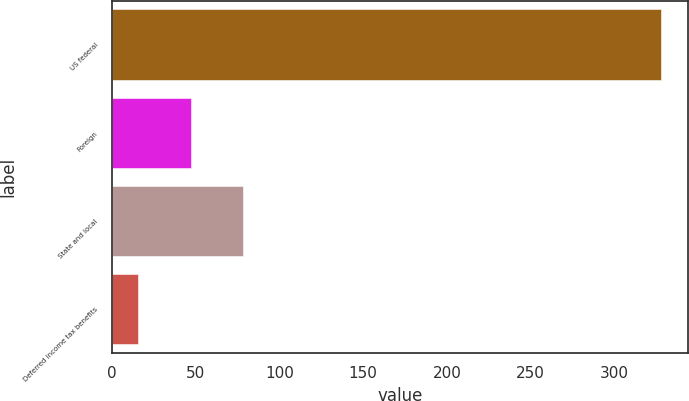Convert chart to OTSL. <chart><loc_0><loc_0><loc_500><loc_500><bar_chart><fcel>US federal<fcel>Foreign<fcel>State and local<fcel>Deferred income tax benefits<nl><fcel>327.7<fcel>46.9<fcel>78.1<fcel>15.7<nl></chart> 